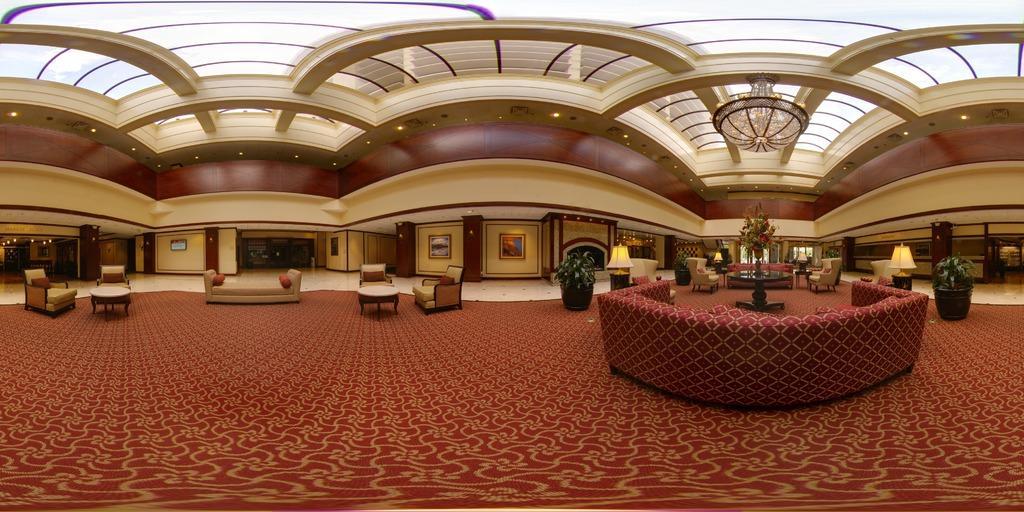Describe this image in one or two sentences. In this image I can see chairs, tables, flower pots, sofas and other objects on the floor. In the background I can see wall which has photos attached to it. This is an inside view of a building. I can also see a chandelier, lights on the ceiling and other objects. 